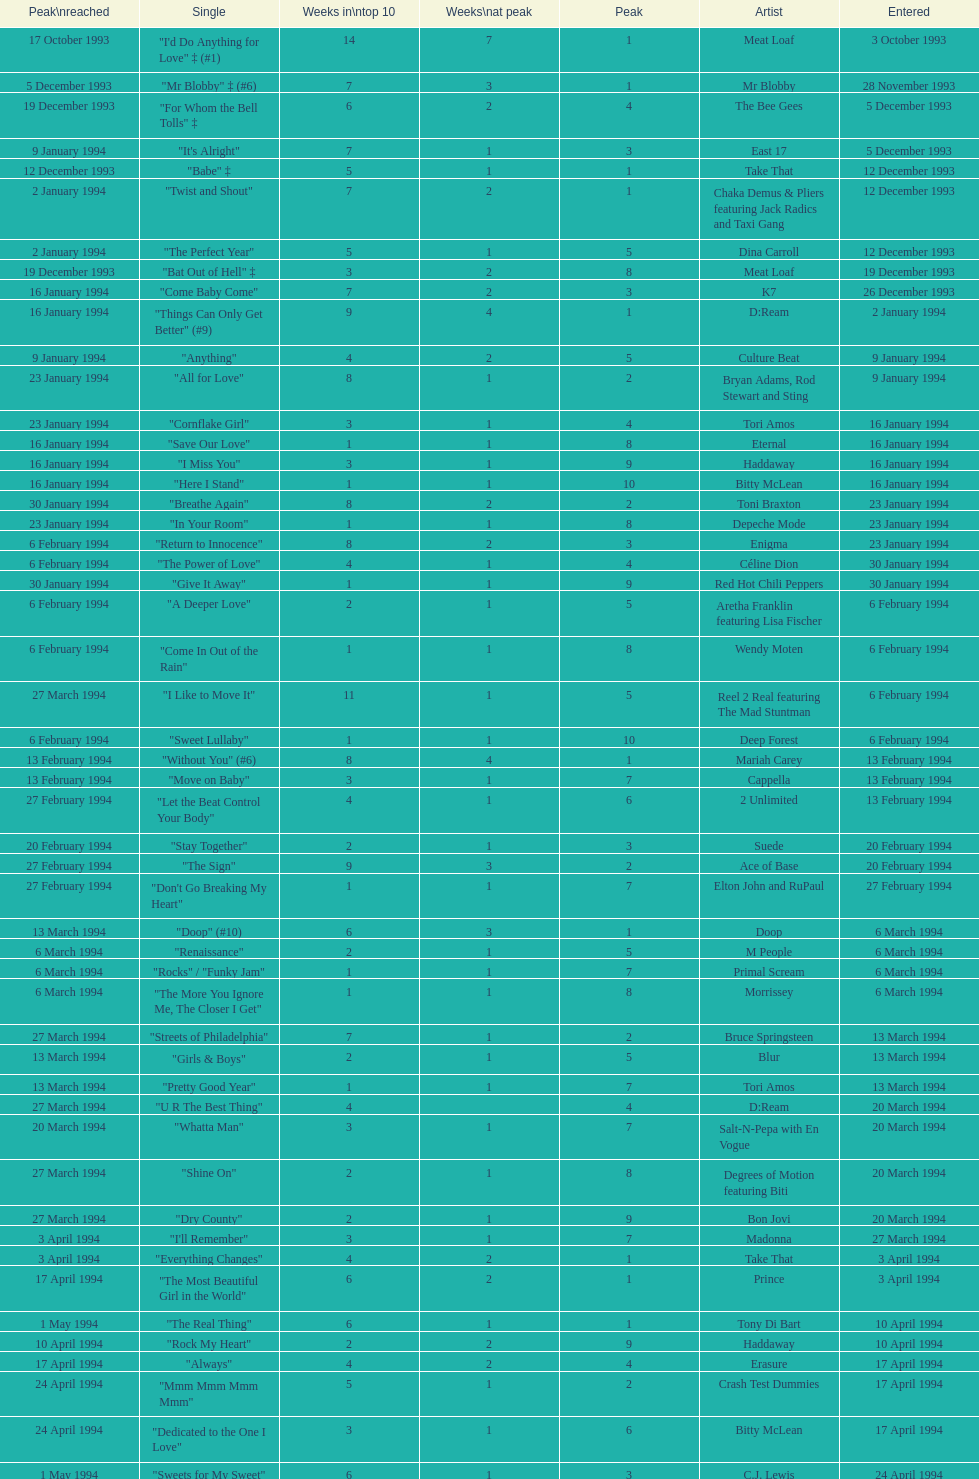This song released by celine dion spent 17 weeks on the uk singles chart in 1994, which one was it? "Think Twice". 